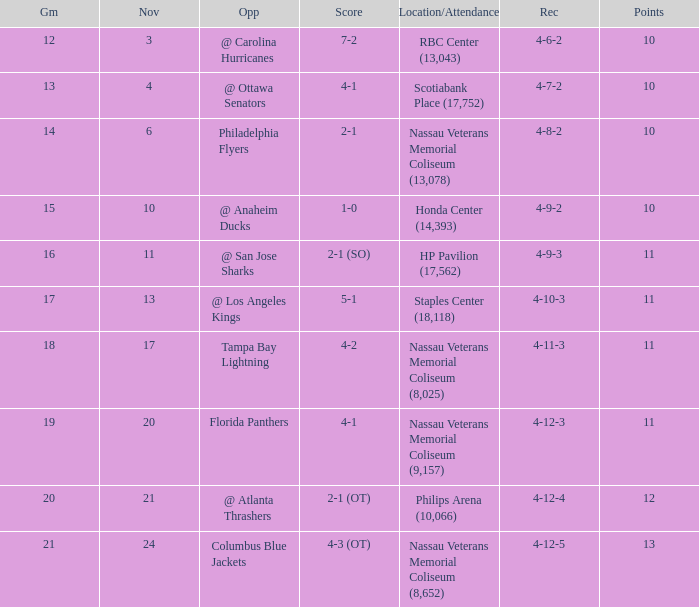Help me parse the entirety of this table. {'header': ['Gm', 'Nov', 'Opp', 'Score', 'Location/Attendance', 'Rec', 'Points'], 'rows': [['12', '3', '@ Carolina Hurricanes', '7-2', 'RBC Center (13,043)', '4-6-2', '10'], ['13', '4', '@ Ottawa Senators', '4-1', 'Scotiabank Place (17,752)', '4-7-2', '10'], ['14', '6', 'Philadelphia Flyers', '2-1', 'Nassau Veterans Memorial Coliseum (13,078)', '4-8-2', '10'], ['15', '10', '@ Anaheim Ducks', '1-0', 'Honda Center (14,393)', '4-9-2', '10'], ['16', '11', '@ San Jose Sharks', '2-1 (SO)', 'HP Pavilion (17,562)', '4-9-3', '11'], ['17', '13', '@ Los Angeles Kings', '5-1', 'Staples Center (18,118)', '4-10-3', '11'], ['18', '17', 'Tampa Bay Lightning', '4-2', 'Nassau Veterans Memorial Coliseum (8,025)', '4-11-3', '11'], ['19', '20', 'Florida Panthers', '4-1', 'Nassau Veterans Memorial Coliseum (9,157)', '4-12-3', '11'], ['20', '21', '@ Atlanta Thrashers', '2-1 (OT)', 'Philips Arena (10,066)', '4-12-4', '12'], ['21', '24', 'Columbus Blue Jackets', '4-3 (OT)', 'Nassau Veterans Memorial Coliseum (8,652)', '4-12-5', '13']]} What is the least entry for game if the score is 1-0? 15.0. 